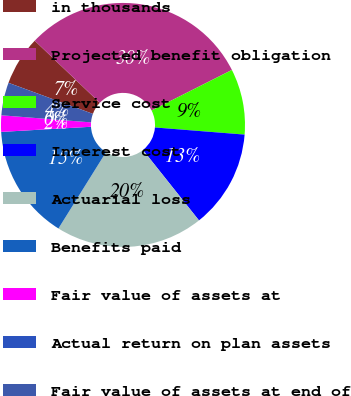Convert chart. <chart><loc_0><loc_0><loc_500><loc_500><pie_chart><fcel>in thousands<fcel>Projected benefit obligation<fcel>Service cost<fcel>Interest cost<fcel>Actuarial loss<fcel>Benefits paid<fcel>Fair value of assets at<fcel>Actual return on plan assets<fcel>Fair value of assets at end of<nl><fcel>6.52%<fcel>30.43%<fcel>8.7%<fcel>13.04%<fcel>19.57%<fcel>15.22%<fcel>2.17%<fcel>0.0%<fcel>4.35%<nl></chart> 